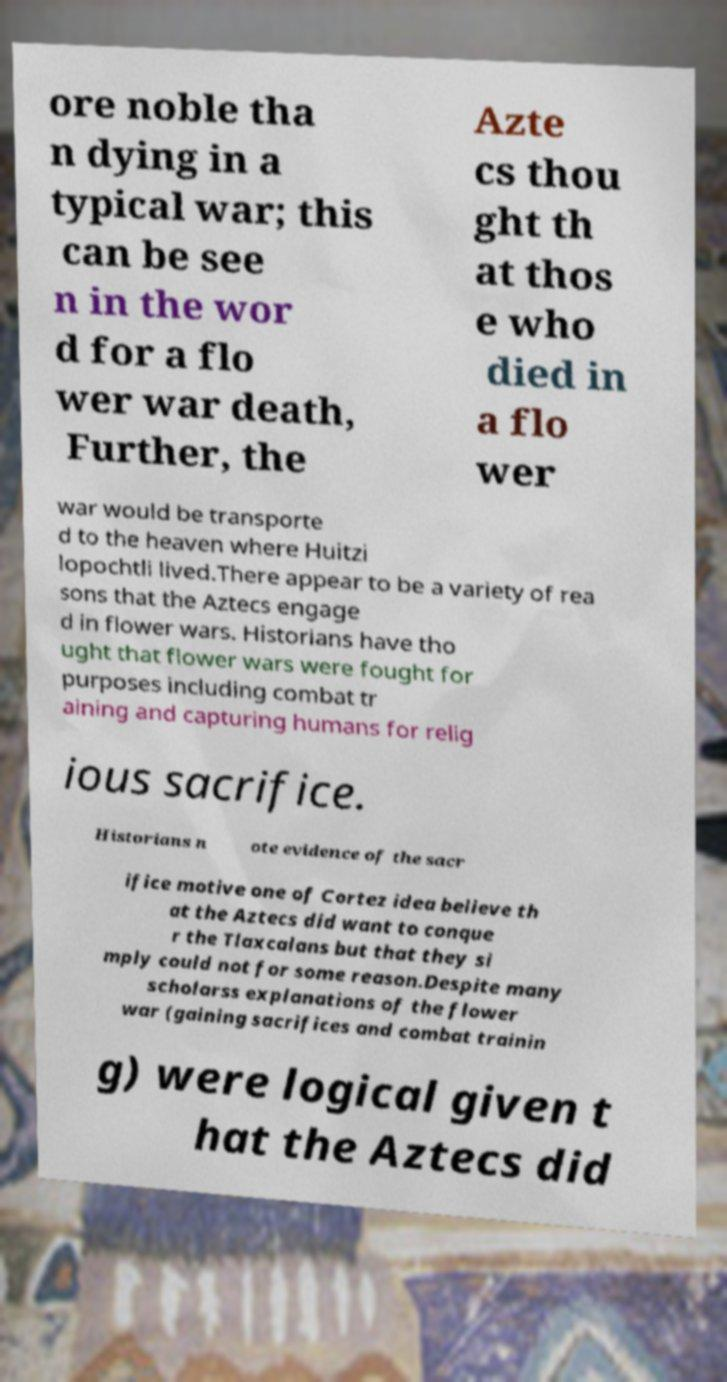There's text embedded in this image that I need extracted. Can you transcribe it verbatim? ore noble tha n dying in a typical war; this can be see n in the wor d for a flo wer war death, Further, the Azte cs thou ght th at thos e who died in a flo wer war would be transporte d to the heaven where Huitzi lopochtli lived.There appear to be a variety of rea sons that the Aztecs engage d in flower wars. Historians have tho ught that flower wars were fought for purposes including combat tr aining and capturing humans for relig ious sacrifice. Historians n ote evidence of the sacr ifice motive one of Cortez idea believe th at the Aztecs did want to conque r the Tlaxcalans but that they si mply could not for some reason.Despite many scholarss explanations of the flower war (gaining sacrifices and combat trainin g) were logical given t hat the Aztecs did 